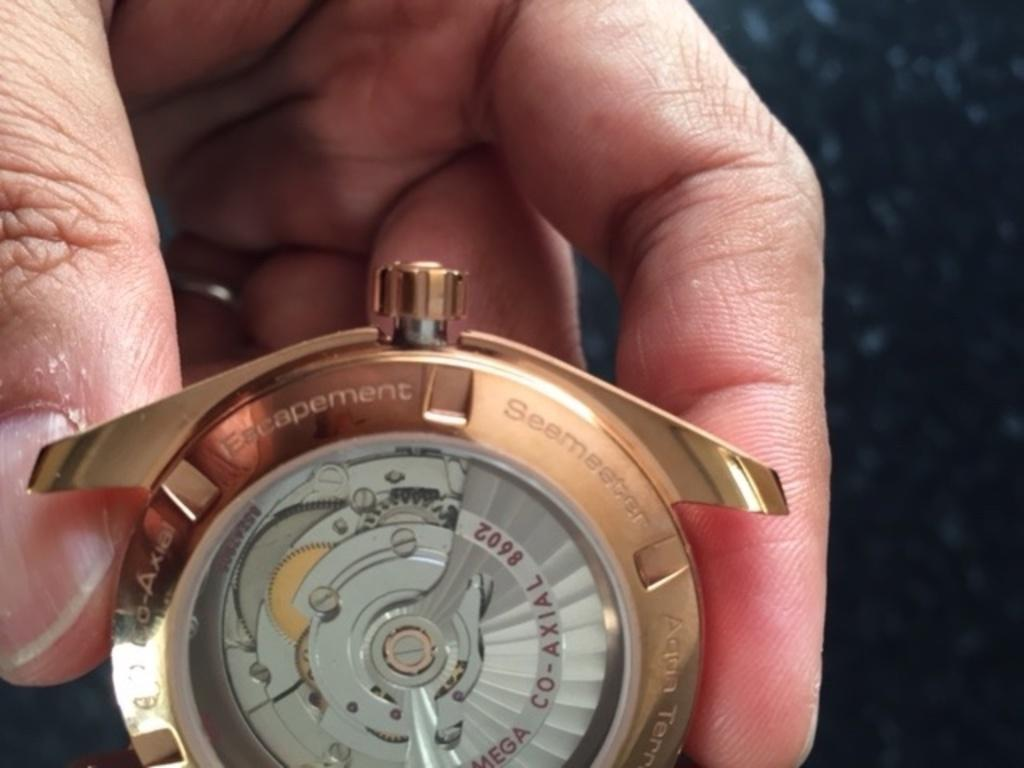<image>
Offer a succinct explanation of the picture presented. A hand is holding a small mechanical piece that has Escapement written across the top. 